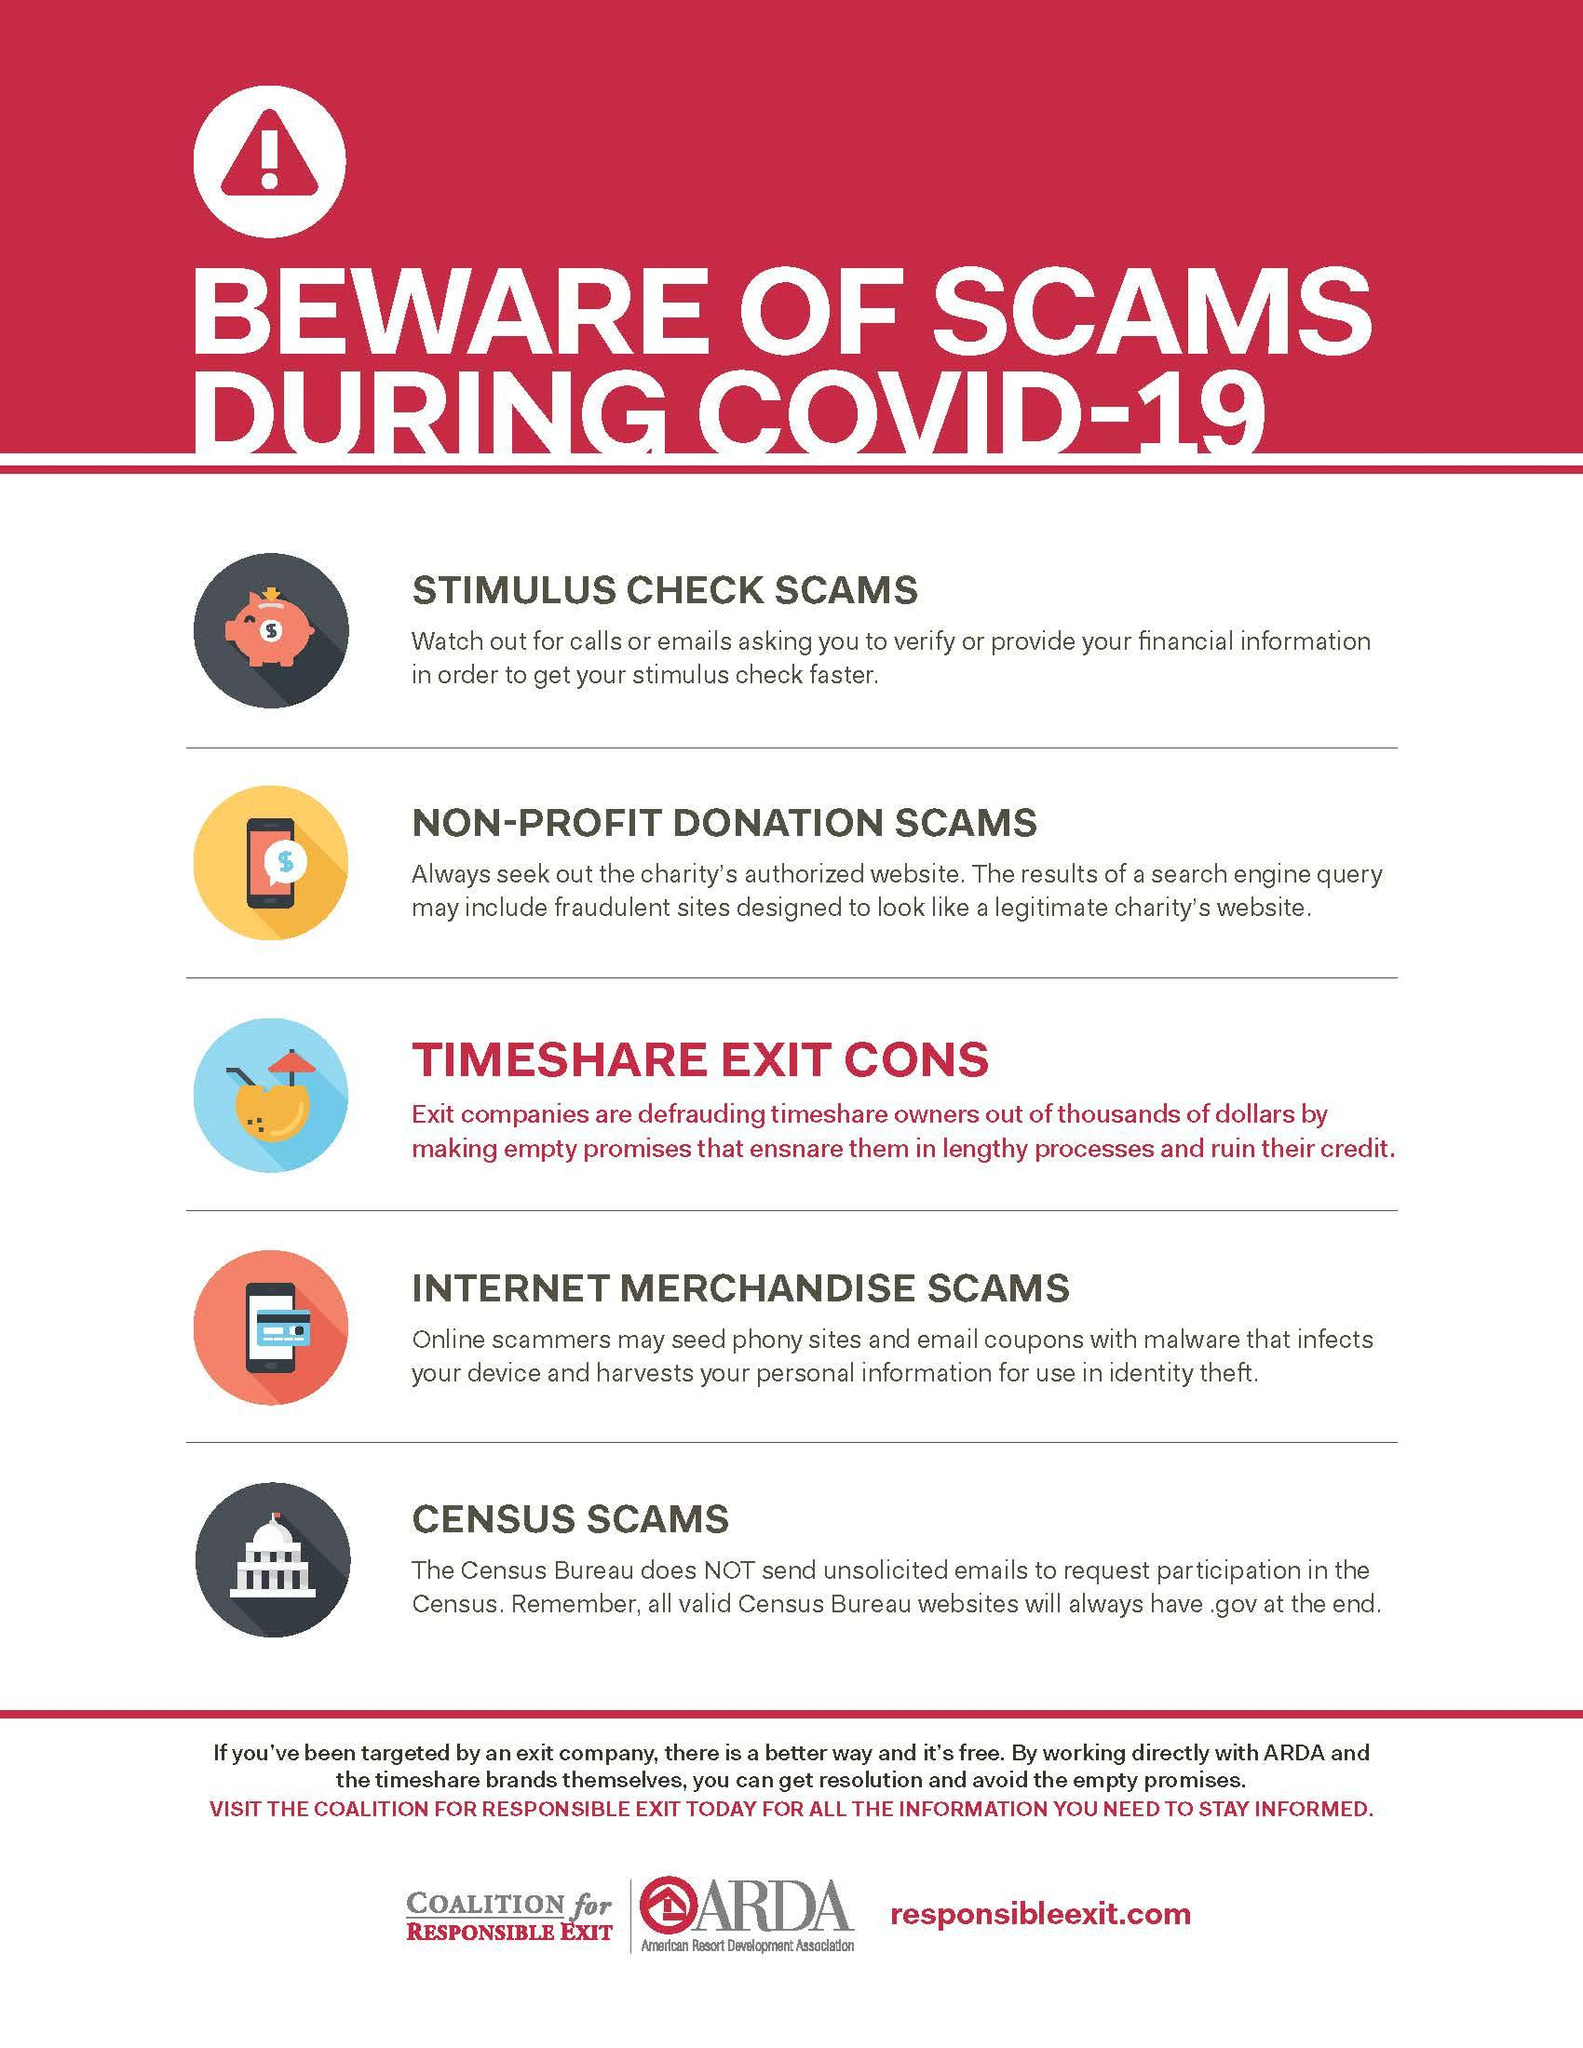Outline some significant characteristics in this image. It has been highlighted that there are 5 types of scams. The electronic card and smart phone indicate the presence of an internet merchandise scam. The piggy bank indicates the type of scam known as stimulus check scams. 